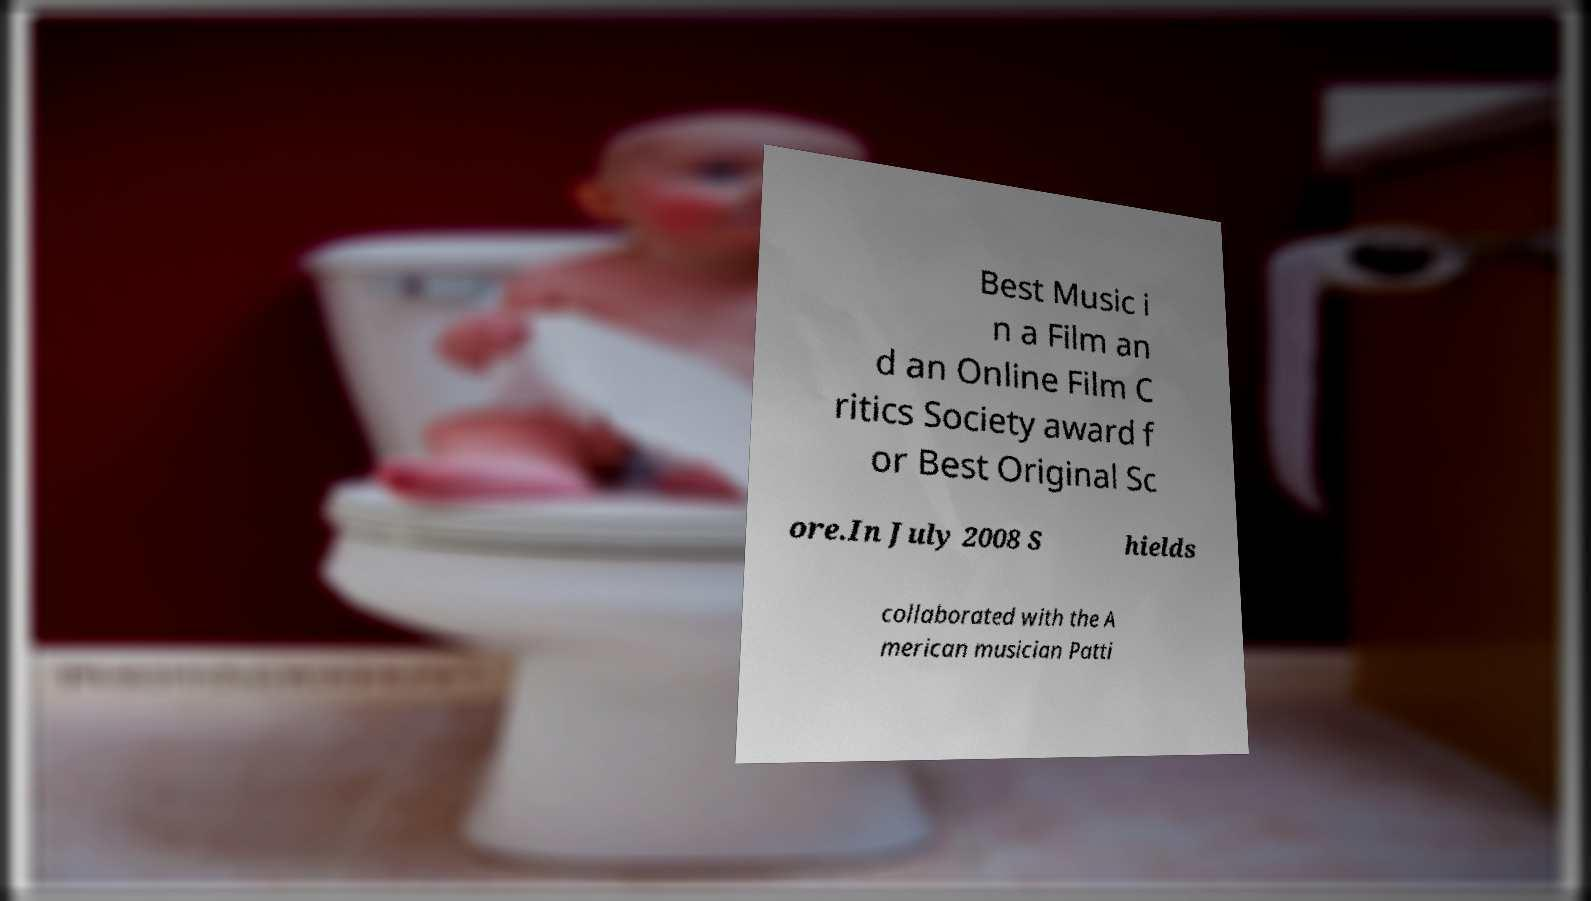Please read and relay the text visible in this image. What does it say? Best Music i n a Film an d an Online Film C ritics Society award f or Best Original Sc ore.In July 2008 S hields collaborated with the A merican musician Patti 